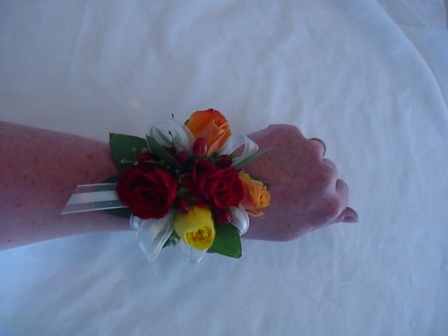What story do you think is behind the making of this corsage? This corsage appears to have been carefully crafted with great attention to detail. It's likely that the florist or individual who made it selected each rose meticulously for its vibrant color and freshness, ensuring a harmonious blend of red, yellow, and orange. The white ribbons were likely chosen to match the white tablecloth, creating a cohesive look. Perhaps the corsage was made for a prom, where a young gentleman had it made to match his date's dress, symbolizing affection and care. Alternatively, it could be for a wedding, crafted by a florist who wanted to ensure the celebration's joyous spirit was encapsulated in this small yet significant piece of floral art. The effort and thought put into the corsage suggest it holds sentimental value, contributing to the special memories of the event. Imagine the story of the person receiving this corsage. Once upon a time, in a quaint little town, there was a young woman named Emily who was attending her senior prom. She had spent weeks picking out the perfect dress, which was a beautiful shade of turquoise. On the day of the prom, her best friend, James, surprised her with this exquisite corsage. It perfectly matched the color scheme of her dress with its vibrant red, yellow, and orange roses, tied together with delicate white ribbons. Emily was overwhelmed with joy and gratitude, knowing the effort James had put into selecting it. As they danced the night away, Emily couldn't help but glance at her corsage, a symbol of their friendship and the memorable night they were sharing. It was a night filled with laughter, dancing, and promises for the future, made all the more special by this carefully crafted piece of floral art on her wrist. If the corsage could talk, what would it say about the event it was a part of? If I could share my story, oh the tales I would tell! I remember the magical evening I was a part of – the laughter, the music, and the twirls of a hundred gowns. I sat proudly on Emily’s wrist, feeling the warmth and excitement pulsing through her veins. As couples danced under the glittering chandeliers, I caught glimpses of beaming smiles and teary-eyed joy. Each sway of the waltz brought me closer to the joyful conversations and sweet whispers. I was there when Emily and James shared their first dance, and I heard their heartfelt promises. I felt the warmth of embraces and the gentleness of hands holding me in admiration. It was an evening of youthful dreams and joyous memories, and I was the silent witness to it all, holding together the colors of love, joy, and friendship. 